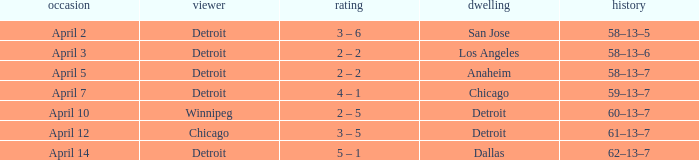Who was the home team in the game having a visitor of Chicago? Detroit. 